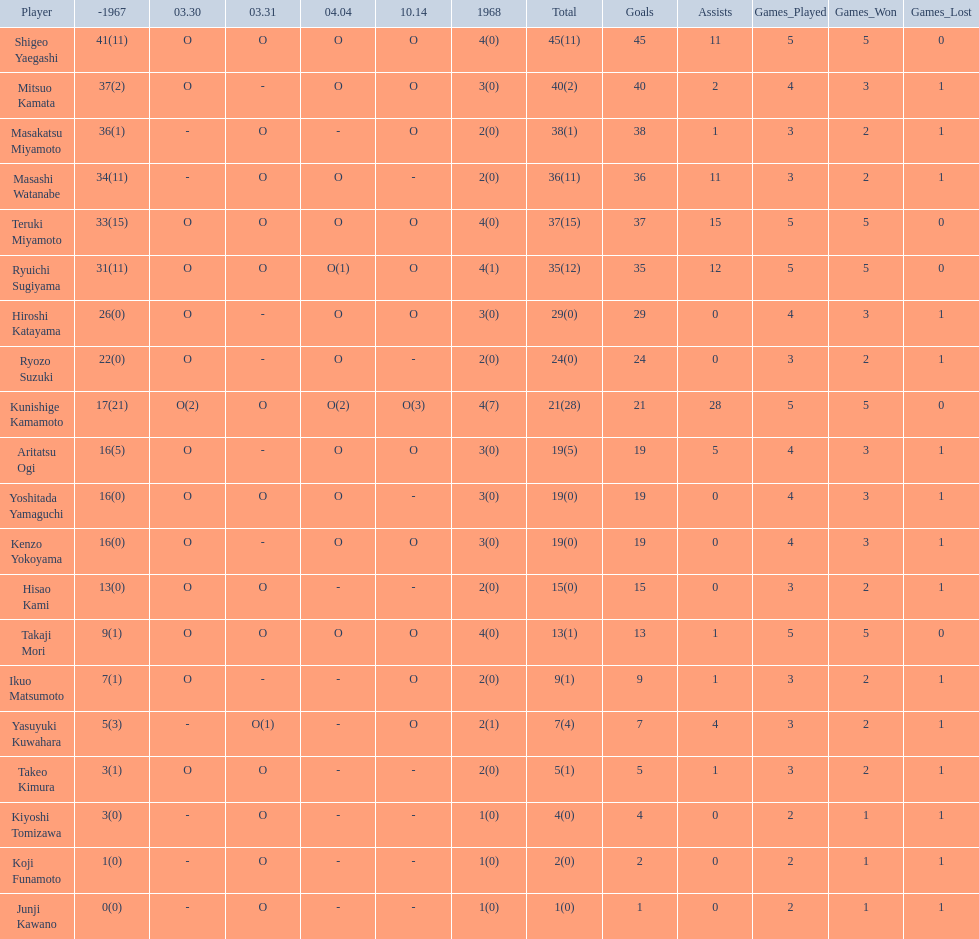How many points did takaji mori have? 13(1). And how many points did junji kawano have? 1(0). To who does the higher of these belong to? Takaji Mori. 